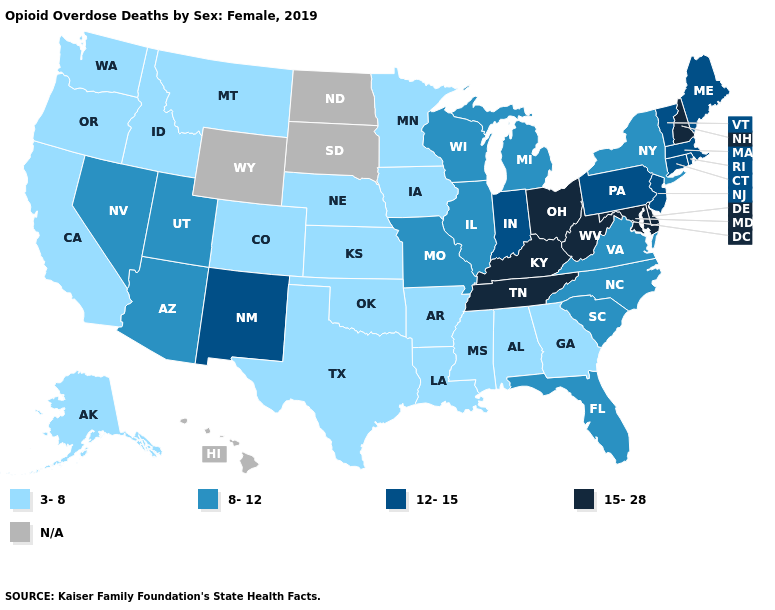Does Utah have the lowest value in the West?
Answer briefly. No. Does New Mexico have the highest value in the West?
Short answer required. Yes. What is the value of North Carolina?
Short answer required. 8-12. Which states have the highest value in the USA?
Concise answer only. Delaware, Kentucky, Maryland, New Hampshire, Ohio, Tennessee, West Virginia. What is the value of Nebraska?
Give a very brief answer. 3-8. What is the lowest value in the MidWest?
Concise answer only. 3-8. Does the first symbol in the legend represent the smallest category?
Quick response, please. Yes. Does the map have missing data?
Answer briefly. Yes. What is the value of Virginia?
Concise answer only. 8-12. How many symbols are there in the legend?
Write a very short answer. 5. What is the value of Oklahoma?
Answer briefly. 3-8. Name the states that have a value in the range N/A?
Answer briefly. Hawaii, North Dakota, South Dakota, Wyoming. 